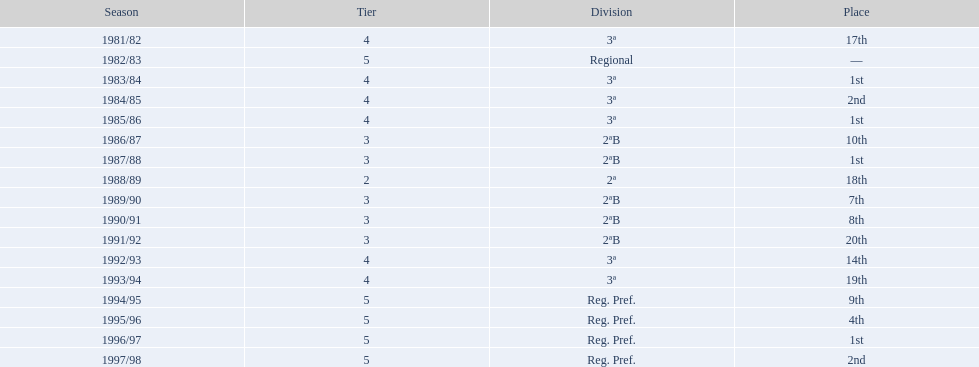In which years did the team end up in 17th place or below? 1981/82, 1988/89, 1991/92, 1993/94. In which of those years did they have the lowest position? 1991/92. 